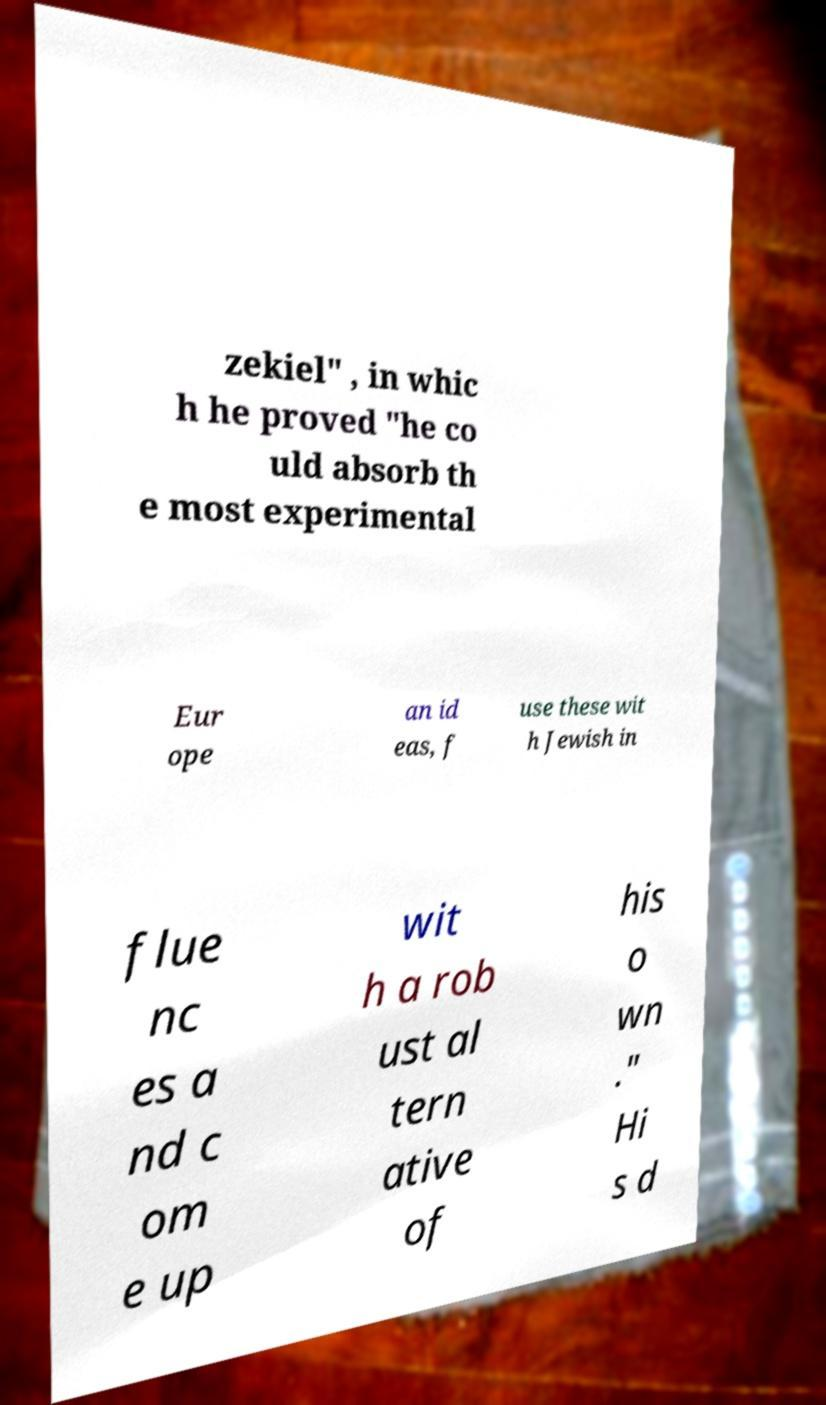Could you assist in decoding the text presented in this image and type it out clearly? zekiel" , in whic h he proved "he co uld absorb th e most experimental Eur ope an id eas, f use these wit h Jewish in flue nc es a nd c om e up wit h a rob ust al tern ative of his o wn ." Hi s d 